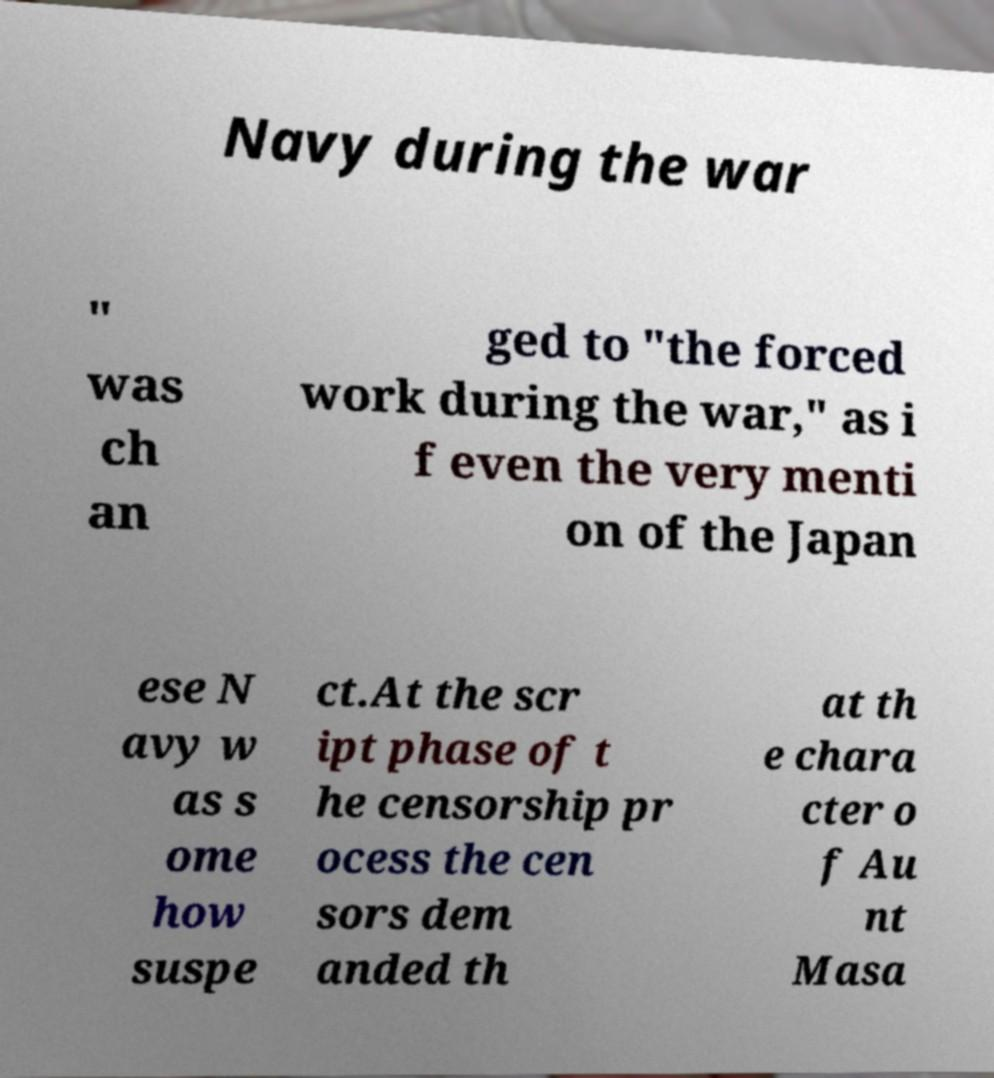For documentation purposes, I need the text within this image transcribed. Could you provide that? Navy during the war " was ch an ged to "the forced work during the war," as i f even the very menti on of the Japan ese N avy w as s ome how suspe ct.At the scr ipt phase of t he censorship pr ocess the cen sors dem anded th at th e chara cter o f Au nt Masa 